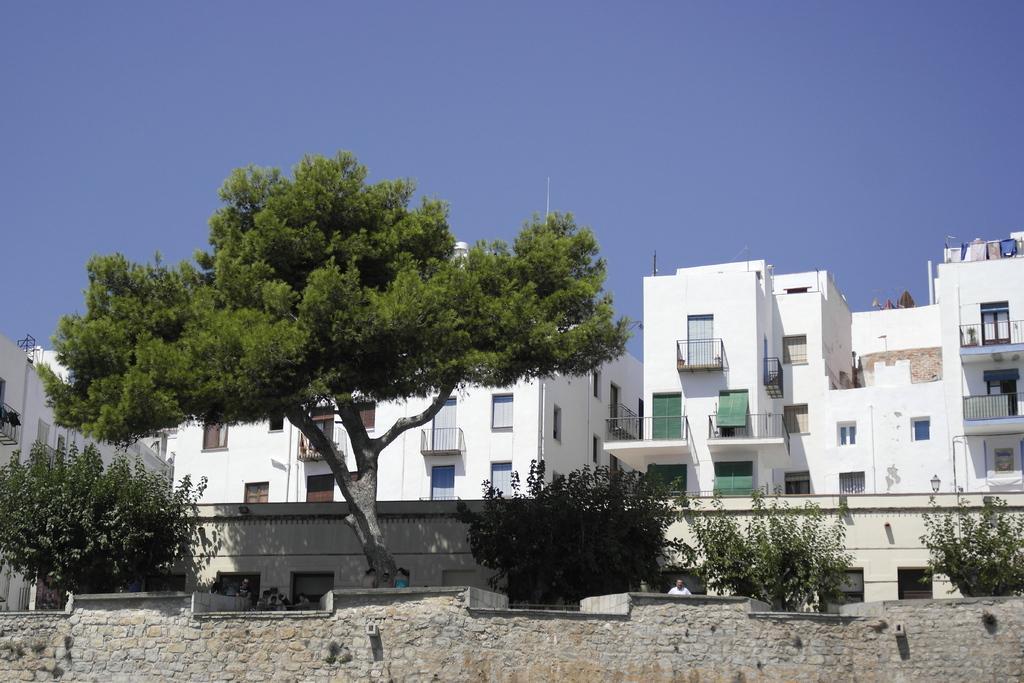Can you describe this image briefly? In this image in the front there is wall. In the center there are trees and in the background there are buildings. 